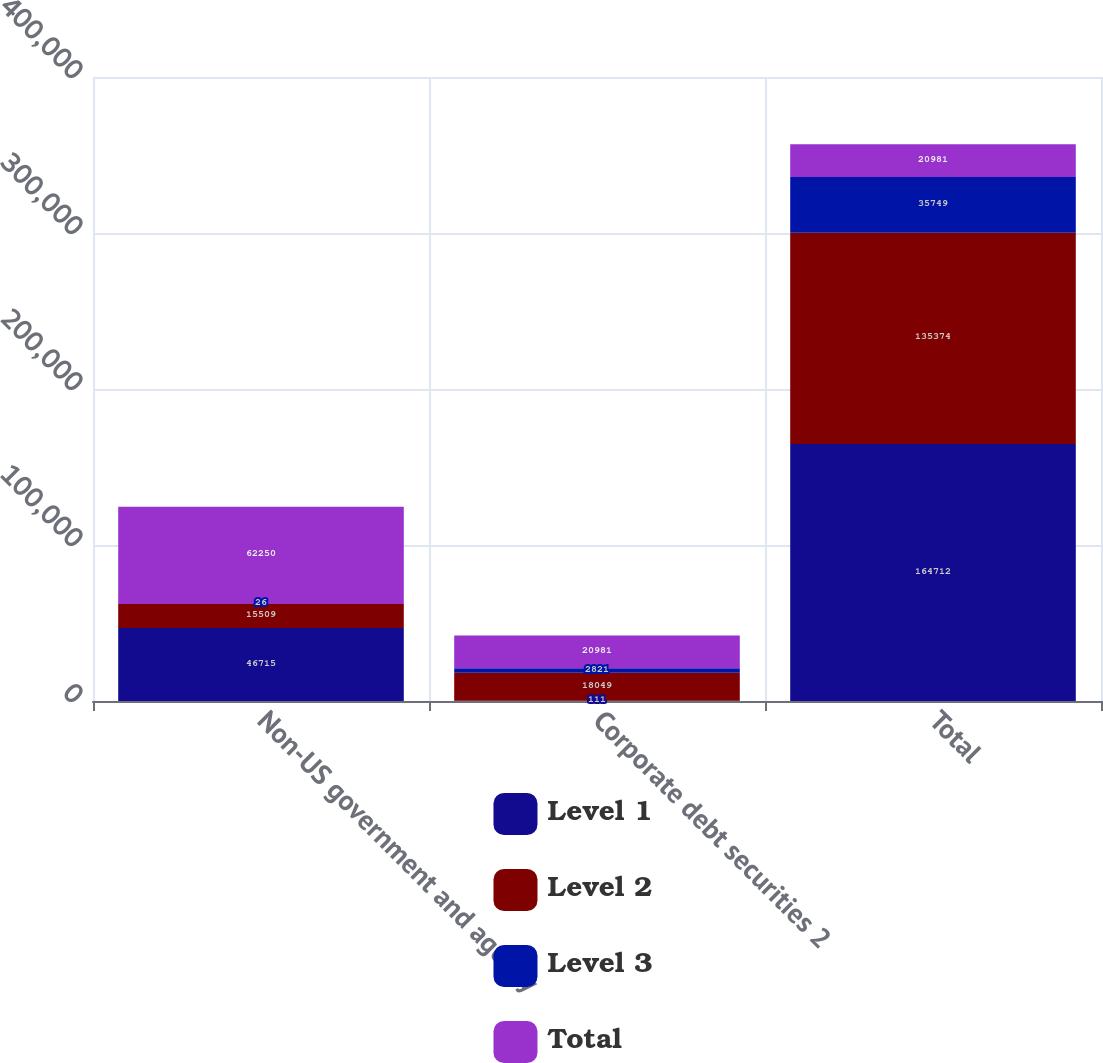Convert chart to OTSL. <chart><loc_0><loc_0><loc_500><loc_500><stacked_bar_chart><ecel><fcel>Non-US government and agency<fcel>Corporate debt securities 2<fcel>Total<nl><fcel>Level 1<fcel>46715<fcel>111<fcel>164712<nl><fcel>Level 2<fcel>15509<fcel>18049<fcel>135374<nl><fcel>Level 3<fcel>26<fcel>2821<fcel>35749<nl><fcel>Total<fcel>62250<fcel>20981<fcel>20981<nl></chart> 